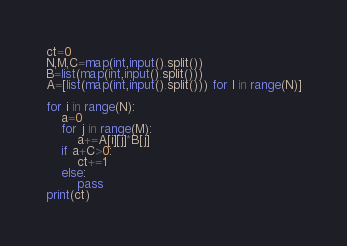<code> <loc_0><loc_0><loc_500><loc_500><_Python_>ct=0
N,M,C=map(int,input().split())
B=list(map(int,input().split()))
A=[list(map(int,input().split())) for l in range(N)]

for i in range(N):
    a=0
    for j in range(M):
        a+=A[i][j]*B[j]
    if a+C>0:
        ct+=1
    else:
        pass
print(ct)



</code> 